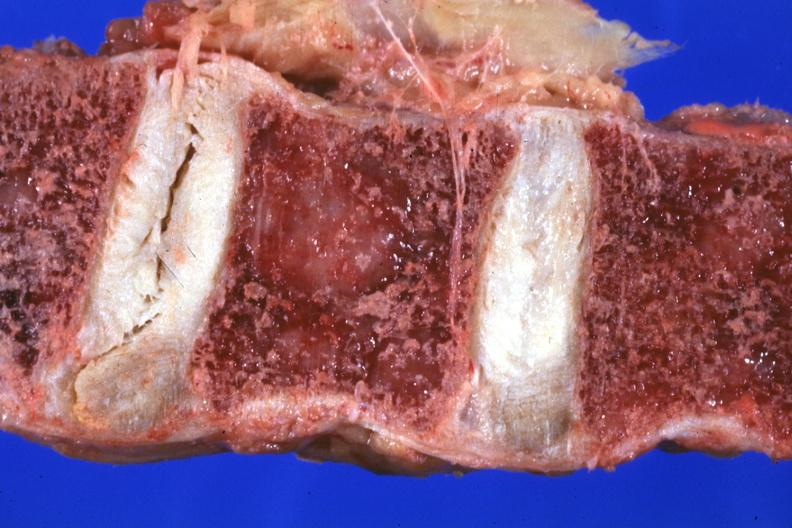s joints present?
Answer the question using a single word or phrase. Yes 